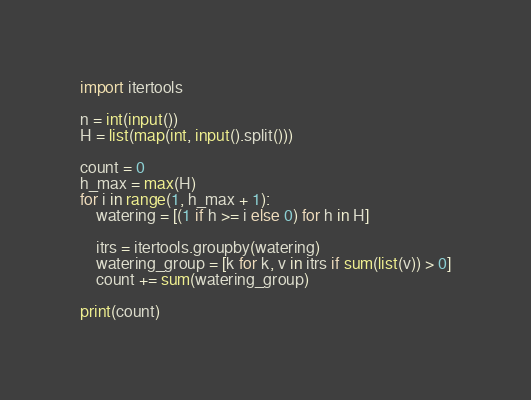<code> <loc_0><loc_0><loc_500><loc_500><_Python_>import itertools

n = int(input())
H = list(map(int, input().split()))

count = 0
h_max = max(H)
for i in range(1, h_max + 1):
    watering = [(1 if h >= i else 0) for h in H]

    itrs = itertools.groupby(watering)
    watering_group = [k for k, v in itrs if sum(list(v)) > 0]
    count += sum(watering_group)

print(count)</code> 